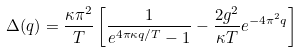<formula> <loc_0><loc_0><loc_500><loc_500>\Delta ( q ) = \frac { \kappa \pi ^ { 2 } } { T } \left [ \frac { 1 } { e ^ { 4 \pi \kappa q / T } - 1 } - \frac { 2 g ^ { 2 } } { \kappa T } e ^ { - 4 \pi ^ { 2 } q } \right ]</formula> 